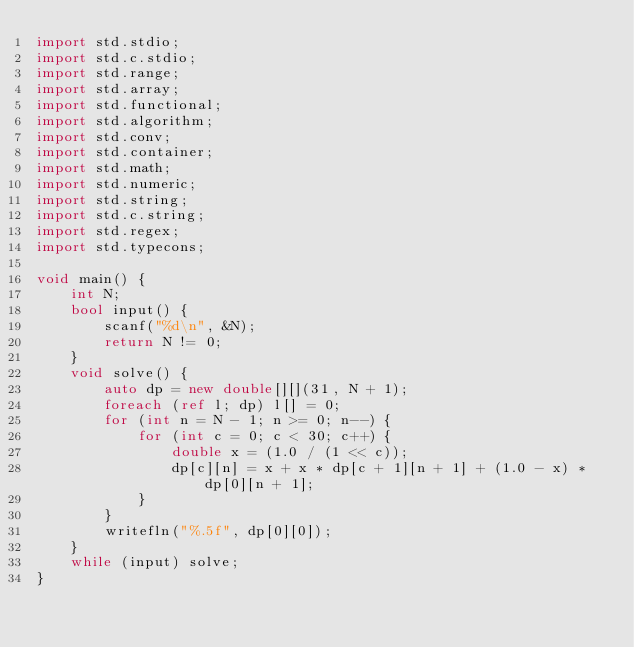<code> <loc_0><loc_0><loc_500><loc_500><_D_>import std.stdio;
import std.c.stdio;
import std.range;
import std.array;
import std.functional;
import std.algorithm;
import std.conv;
import std.container;
import std.math;
import std.numeric;
import std.string;
import std.c.string;
import std.regex;
import std.typecons;
 
void main() {
    int N;
    bool input() {
        scanf("%d\n", &N);
        return N != 0;
    }
    void solve() {
        auto dp = new double[][](31, N + 1);
        foreach (ref l; dp) l[] = 0;
        for (int n = N - 1; n >= 0; n--) {
            for (int c = 0; c < 30; c++) {
                double x = (1.0 / (1 << c));
                dp[c][n] = x + x * dp[c + 1][n + 1] + (1.0 - x) * dp[0][n + 1];
            }
        }
        writefln("%.5f", dp[0][0]);
    }
    while (input) solve;
}</code> 